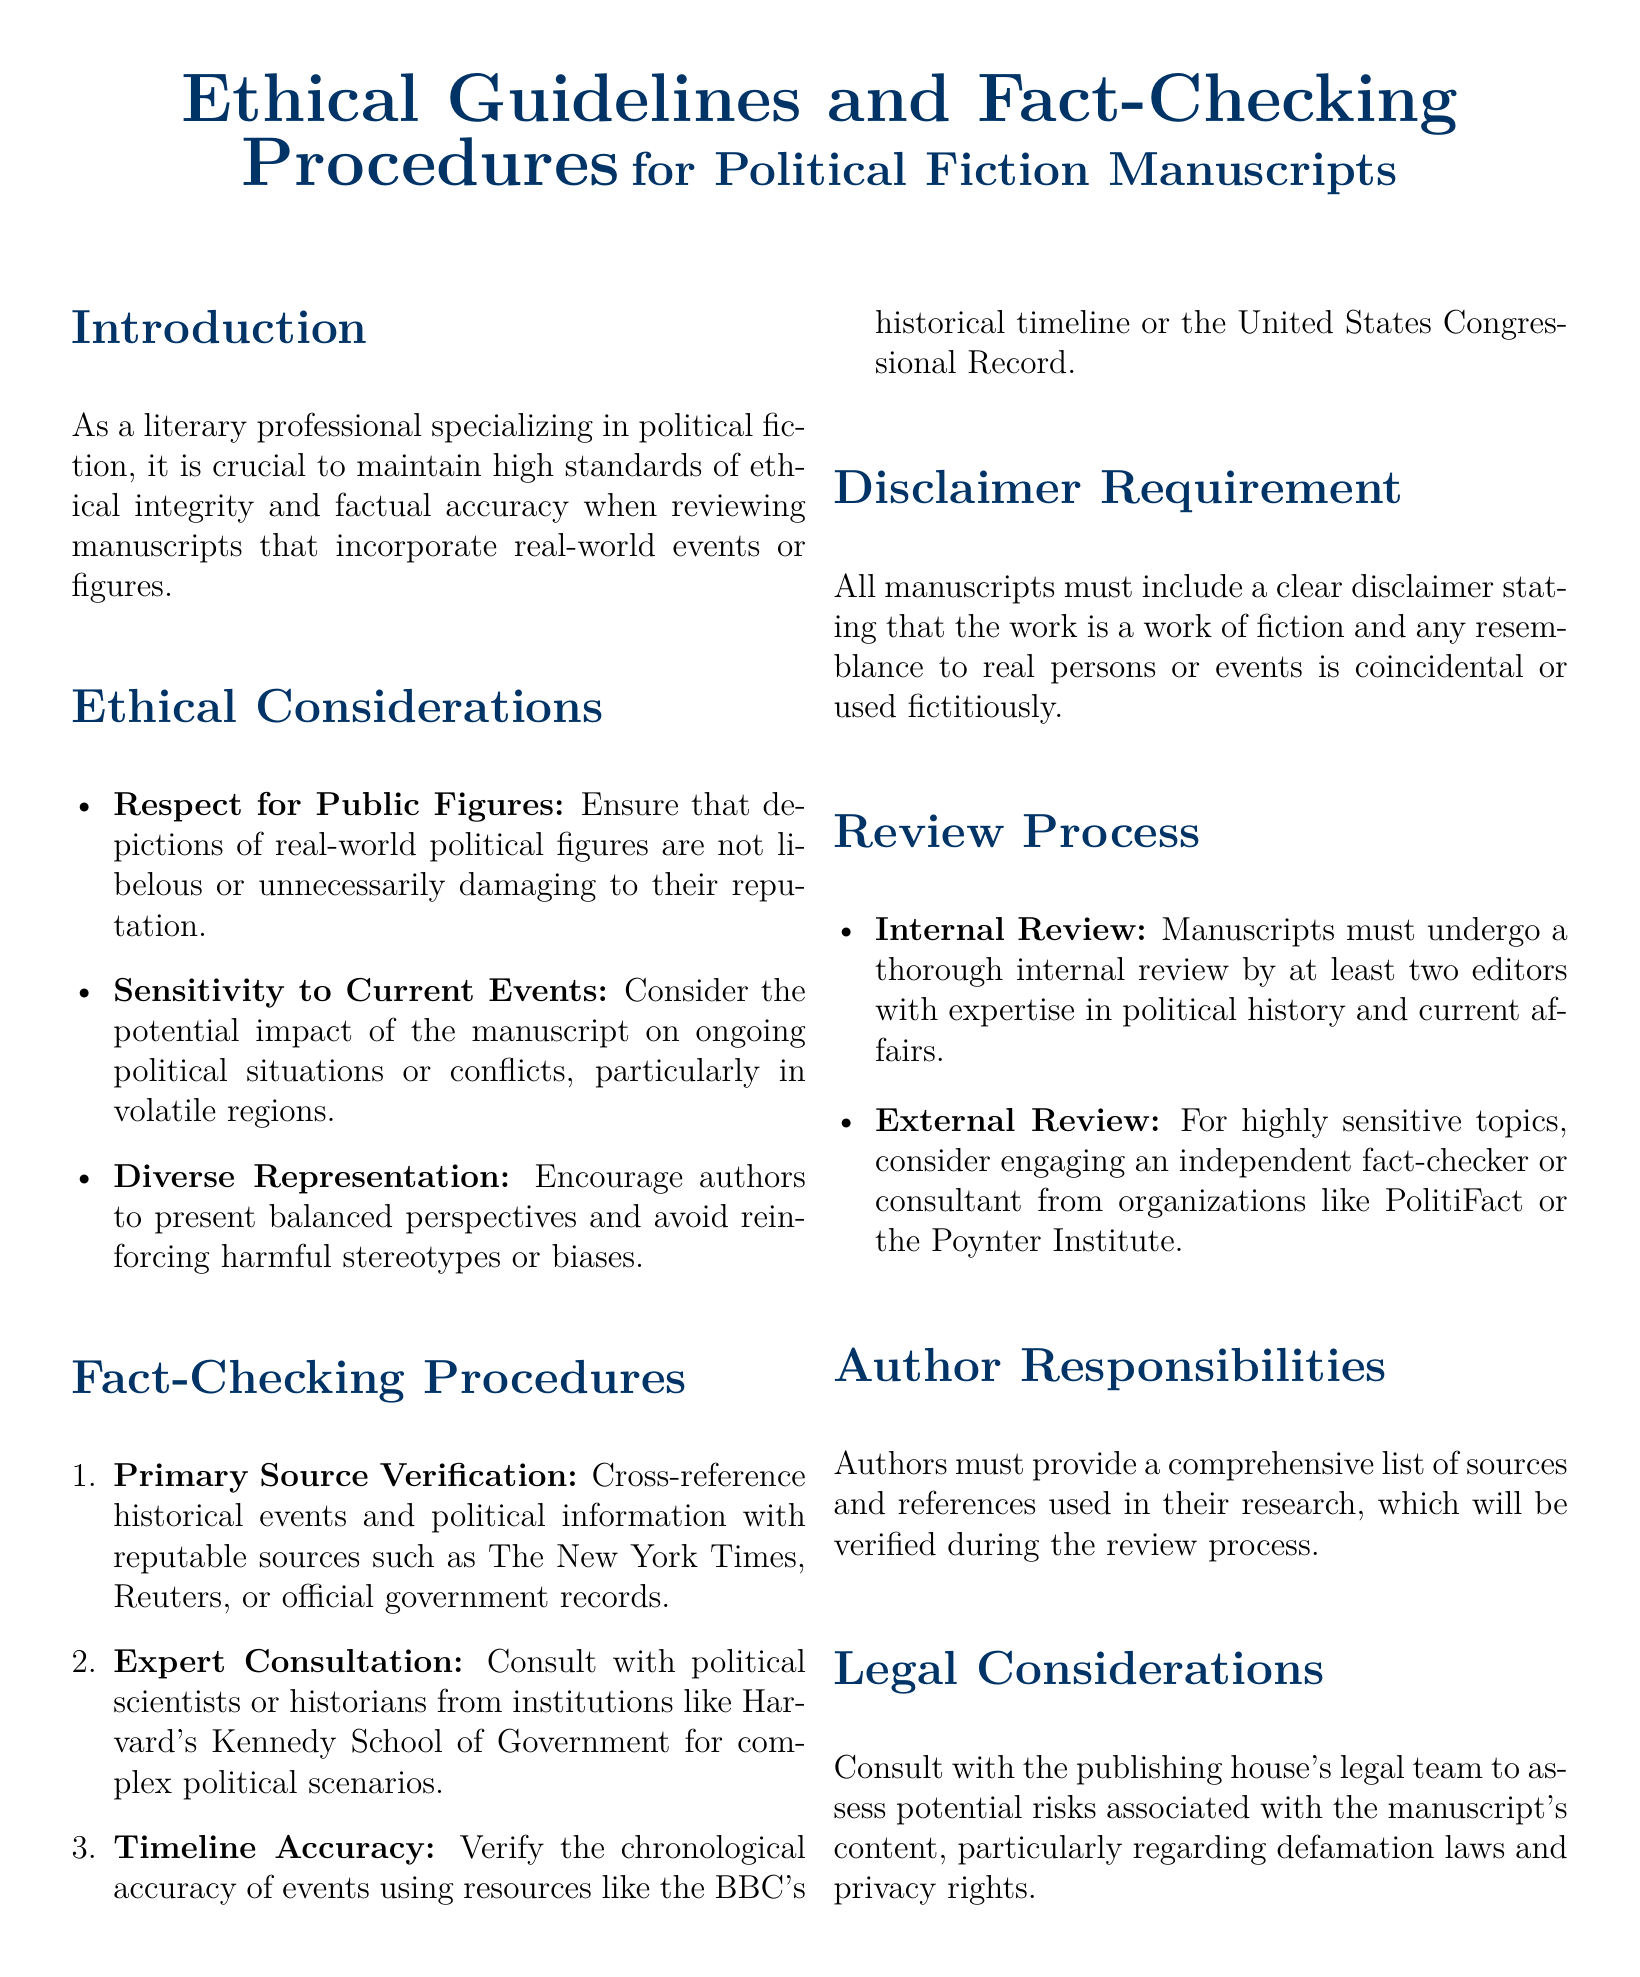What are the ethical considerations listed in the document? The ethical considerations are sections detailing specific aspects that must be respected when dealing with political fiction and real-world figures. They include Respect for Public Figures, Sensitivity to Current Events, and Diverse Representation.
Answer: Respect for Public Figures, Sensitivity to Current Events, Diverse Representation How many editors must review manuscripts internally? The document specifies that manuscripts must undergo a thorough internal review by at least two editors.
Answer: At least two editors Which institutions are suggested for expert consultation? The document mentions that political scientists or historians from institutions like Harvard's Kennedy School of Government should be consulted.
Answer: Harvard's Kennedy School of Government What type of disclaimer is required for manuscripts? The document states that all manuscripts must include a clear disclaimer indicating that the work is fictional and any resemblance to real persons or events is coincidental.
Answer: A clear disclaimer What is the main focus of this policy document? The document is focused on outlining ethical guidelines and fact-checking procedures for political fiction manuscripts incorporating real-world events or figures.
Answer: Ethical guidelines and fact-checking procedures What should authors provide in terms of sources? Authors are required to provide a comprehensive list of sources and references used in their research, which will be verified during the review process.
Answer: A comprehensive list of sources and references 